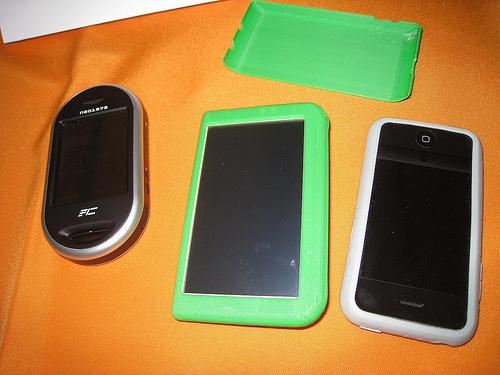Provide a brief summary of the main objects in the image. Three mobile phones on an orange cloth, two with white cases and one with a green case, and a white paper beside them. Briefly describe the color scheme of the image. The image has a combination of orange, white, black, grey, and green colors. Mention the number of phones in the image and their respective case colors. There are three phones - one with a white case, another with a white case, and the third with a green case. Identify the number of phones with white cases in the image. There are two phones with white cases in the image. Describe the color and material of the surface where the objects are placed. The objects are placed on an orange-colored cloth, possibly made of fabric. Explain the main focus of the image in one sentence. The image showcases three mobile phones with different colored cases on an orange cloth. Describe the color contrast between the tablecloth and mobile cases. The tablecloth's orange color contrasts against the white and green mobile cases. Comment on the size of the objects in the image relative to each other. The mobile phones are all roughly similar in size, and the white paper appears smaller in comparison. State a noticeable detail about the white and black phone in the image. The phone appears to be an iPhone with a white case and a fingerprint on its screen. In a short sentence, describe the appearance of the green mobile cover. The green mobile cover is a solid color, possibly made of plastic or rubber material. 